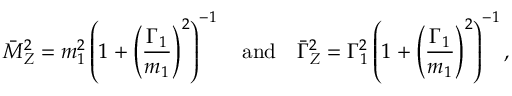<formula> <loc_0><loc_0><loc_500><loc_500>\bar { M } _ { Z } ^ { 2 } = m _ { 1 } ^ { 2 } \left ( 1 + \left ( \frac { \Gamma _ { 1 } } { m _ { 1 } } \right ) ^ { 2 } \right ) ^ { - 1 } \quad a n d \quad \bar { \Gamma } _ { Z } ^ { 2 } = \Gamma _ { 1 } ^ { 2 } \left ( 1 + \left ( \frac { \Gamma _ { 1 } } { m _ { 1 } } \right ) ^ { 2 } \right ) ^ { - 1 } ,</formula> 